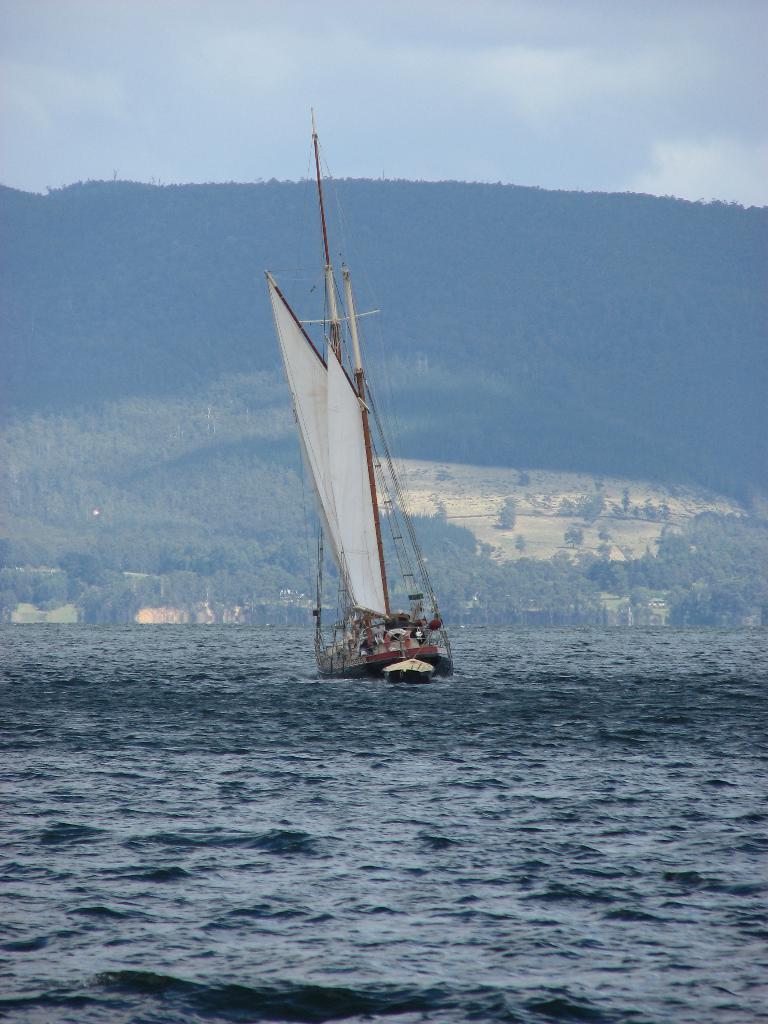Describe this image in one or two sentences. In this image we can see sailboat is floating on the water. In the background, we can see the trees, hills and the cloudy sky. 